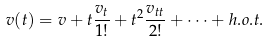<formula> <loc_0><loc_0><loc_500><loc_500>v ( t ) = v + t \frac { v _ { t } } { 1 ! } + { t ^ { 2 } } \frac { v _ { t t } } { 2 ! } + \dots + h . o . t .</formula> 